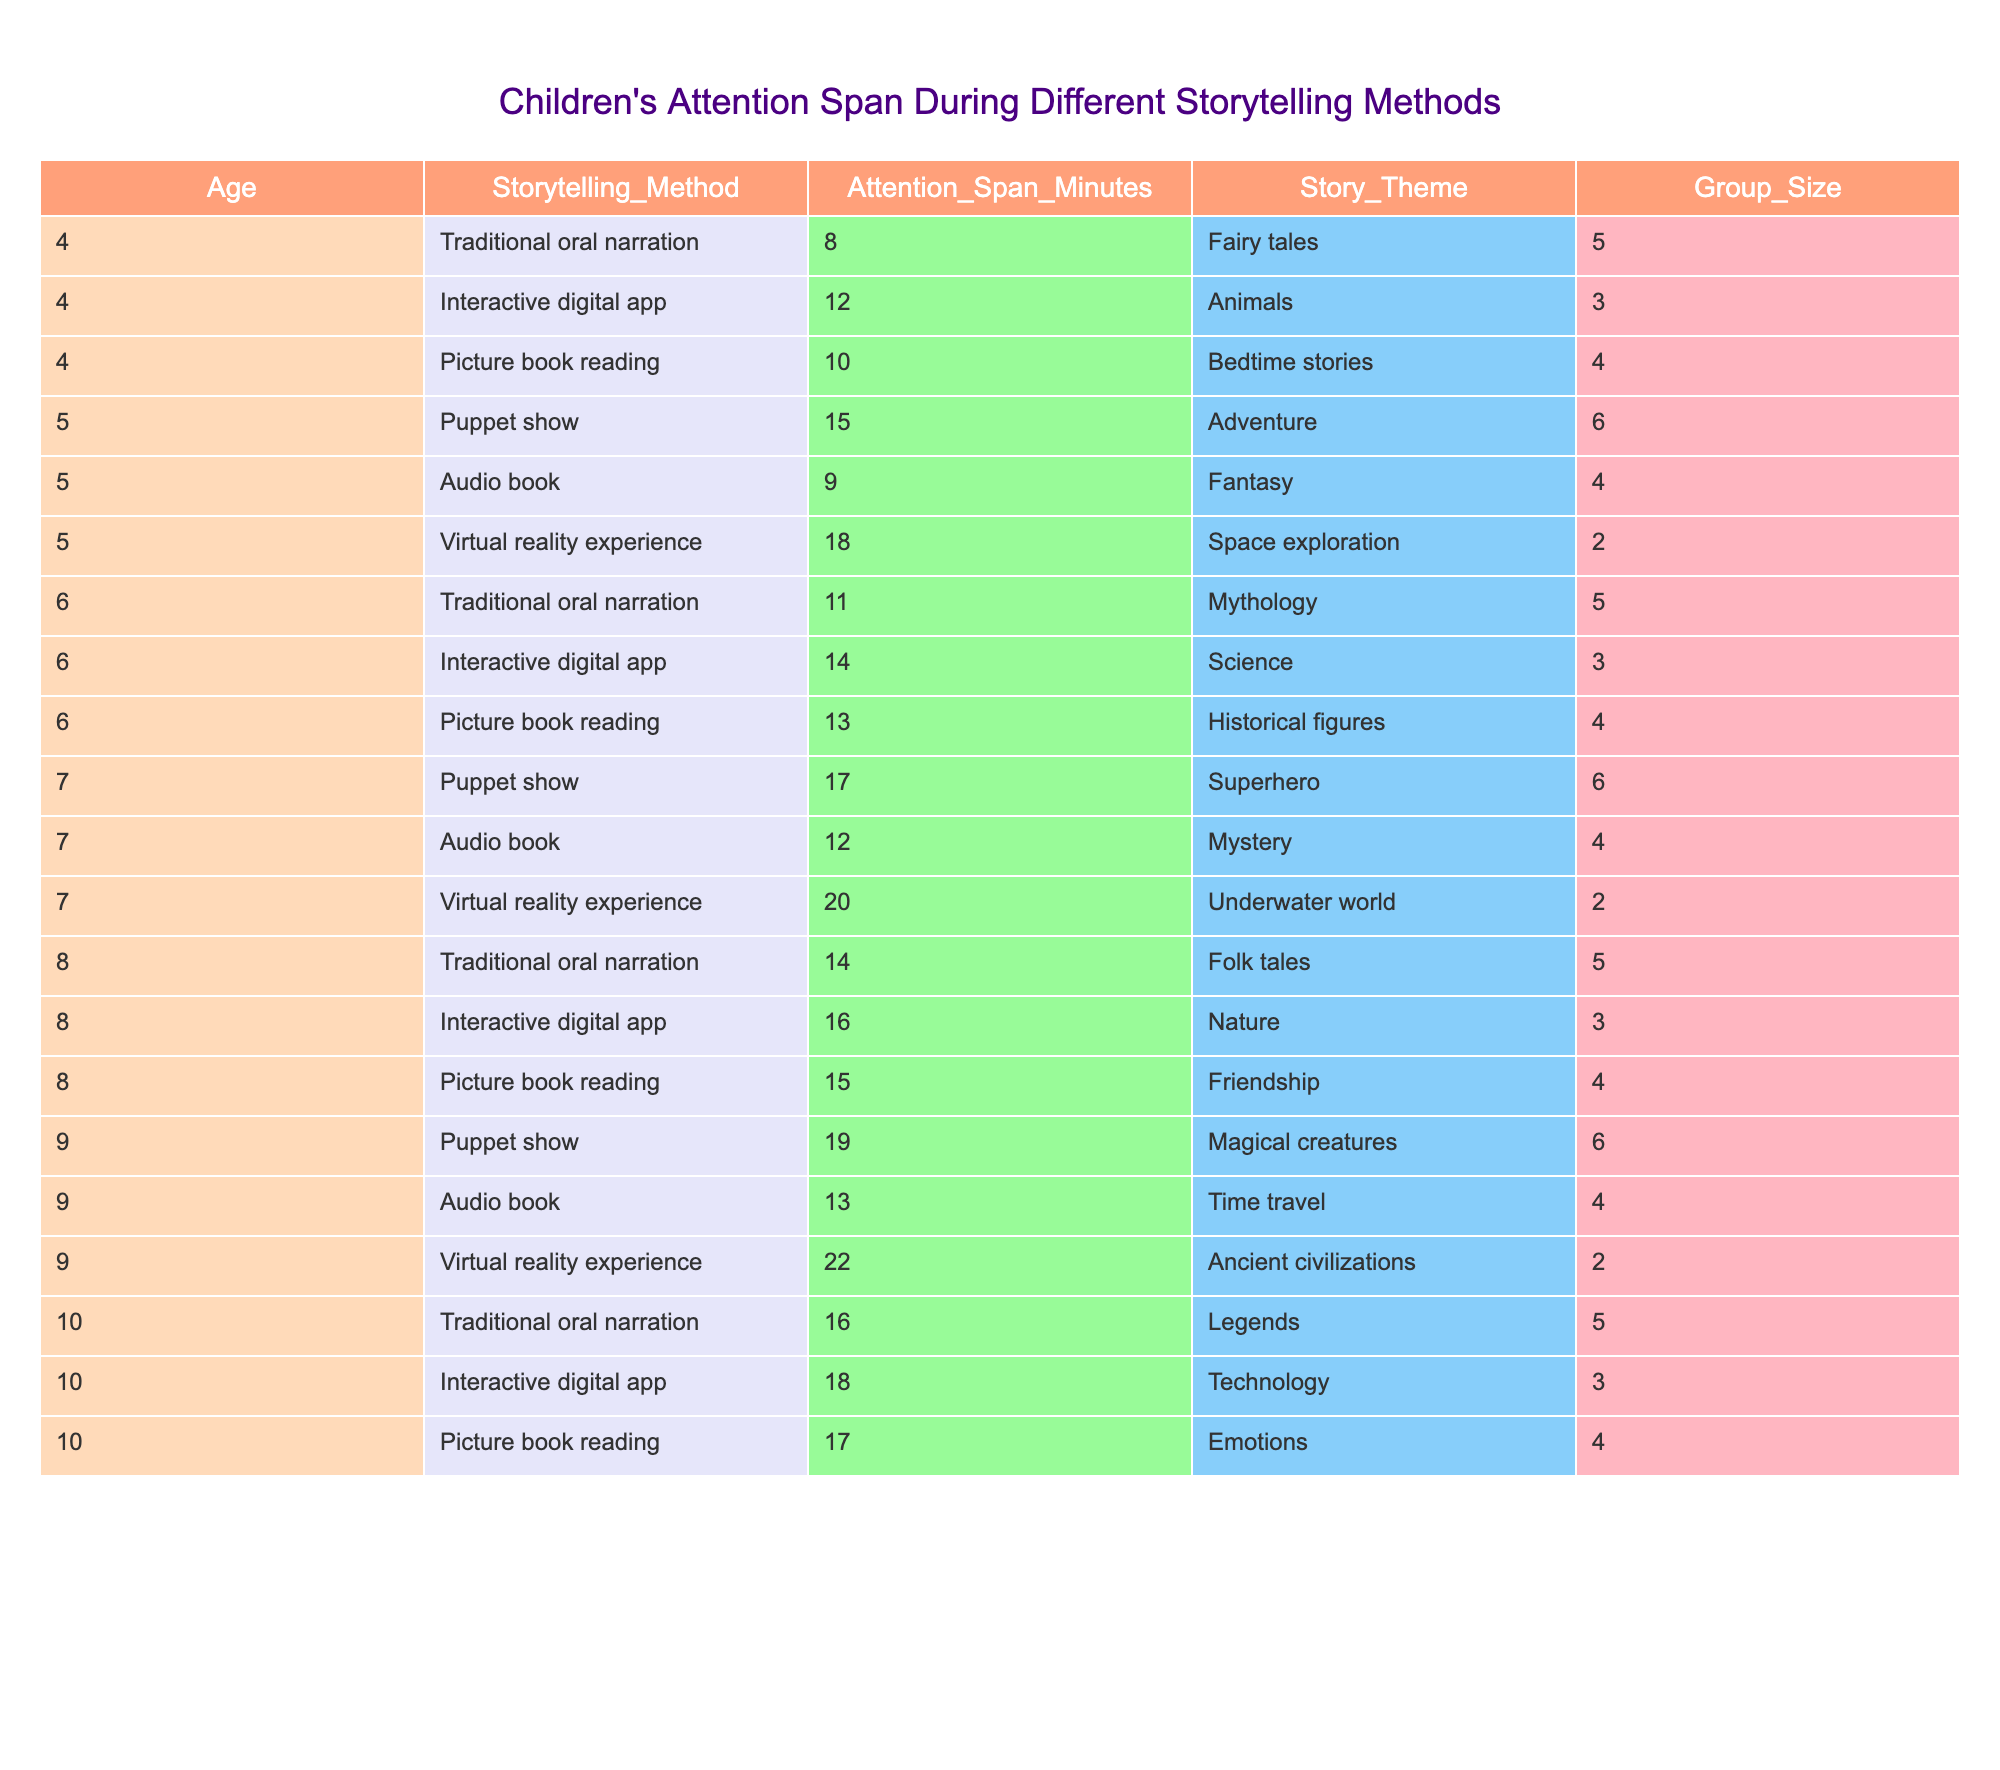What is the maximum attention span recorded in the table? The maximum attention span is 22 minutes for the storytelling method "Virtual reality experience" with the story theme "Ancient civilizations" involving children aged 9.
Answer: 22 What is the attention span for children aged 5 when using a Puppet show? For children aged 5, the attention span during a Puppet show is 15 minutes.
Answer: 15 How many storytelling methods have an attention span of 18 minutes or more? There are four storytelling methods that have an attention span of 18 minutes or more: "Virtual reality experience" at 18 minutes, "Interactive digital app" at 18 minutes, and "Virtual reality experience" at 22 minutes.
Answer: 4 Which age group shows the highest attention span with "Interactive digital app"? The age group of 10 shows the highest attention span with "Interactive digital app" at 18 minutes.
Answer: 10 Is there any storytelling method that received the same attention span from two different age groups? Yes, "Traditional oral narration" received an attention span of 16 minutes from both age groups 9 and 10.
Answer: Yes What is the average attention span for storytelling methods involving 4-age children? The attention spans for 4-age children are: 8, 12, and 10 minutes, totaling 30 minutes. Dividing by 3 gives an average attention span of 10 minutes.
Answer: 10 How does the attention span of children aged 6 using an Interactive digital app compare to that of children aged 5 using a similar method? Children aged 6 have an attention span of 14 minutes using an Interactive digital app, while children aged 5 have an attention span of 9 minutes using an Audio book. Therefore, 6-age children's attention span is greater than 5-age children's attention span by 5 minutes.
Answer: 5 minutes difference What is the theme of the storytelling method with the longest attention span? The theme with the longest attention span, which is 22 minutes, is "Ancient civilizations" in a "Virtual reality experience."
Answer: Ancient civilizations Which storytelling method is the least engaging for children aged 4? For children aged 4, the least engaging storytelling method is "Traditional oral narration," with an attention span of 8 minutes.
Answer: Traditional oral narration If we sum the attention spans from all storytelling methods under the age of 8, what is the total? The individual attention spans for children under 8 years old are: 8, 12, 10, 15, 9, 18, 11, 14, 13, 17, 12, 20, 14, 16, and 15 minutes. Summing these values gives a total of 196 minutes.
Answer: 196 